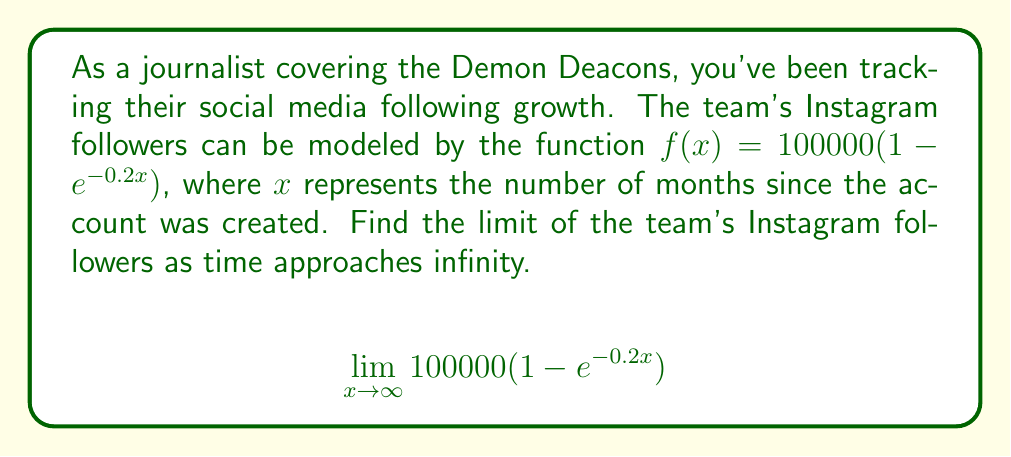Provide a solution to this math problem. Let's approach this step-by-step:

1) First, let's identify the important parts of our function:
   $f(x) = 100000(1 - e^{-0.2x})$

2) As $x$ approaches infinity, we need to focus on what happens to $e^{-0.2x}$:
   
   As $x \to \infty$, $-0.2x \to -\infty$

3) We know that:
   $\lim_{x \to -\infty} e^x = 0$

4) Therefore:
   $\lim_{x \to \infty} e^{-0.2x} = 0$

5) Now, let's substitute this back into our original function:

   $\lim_{x \to \infty} 100000(1 - e^{-0.2x})$
   $= 100000(1 - 0)$
   $= 100000$

6) This makes sense in the context of the problem. As time goes on indefinitely, the number of followers approaches but never quite reaches 100,000.
Answer: 100000 